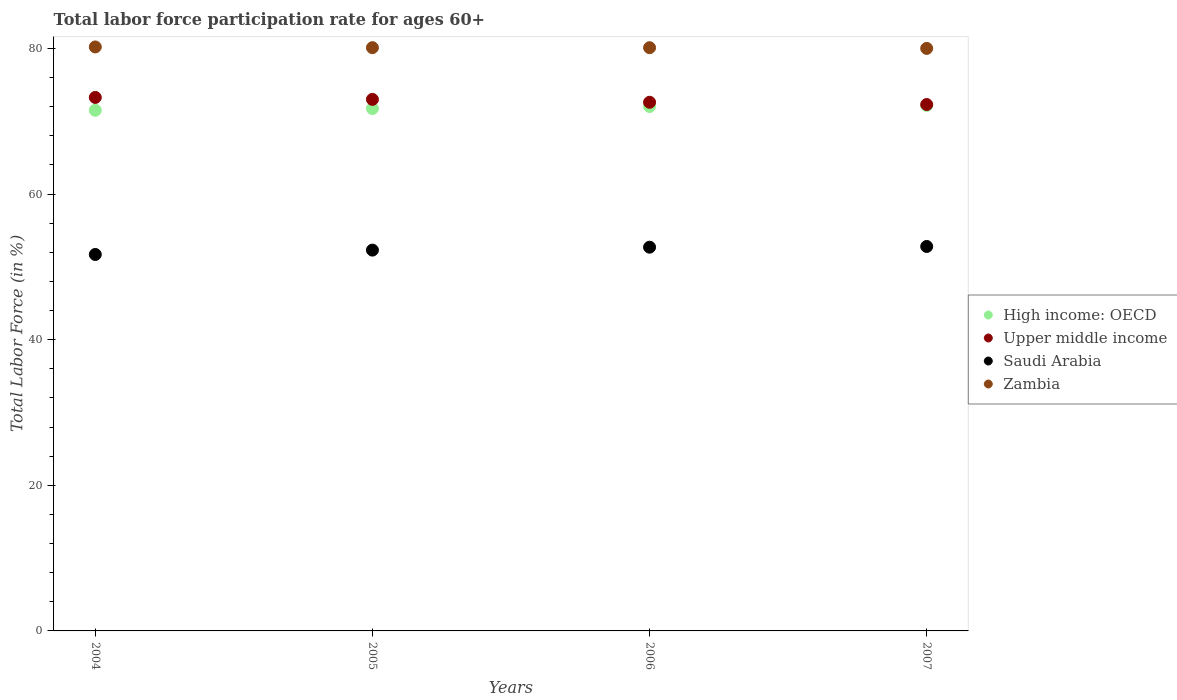What is the labor force participation rate in High income: OECD in 2007?
Your response must be concise. 72.18. Across all years, what is the maximum labor force participation rate in Upper middle income?
Make the answer very short. 73.27. In which year was the labor force participation rate in Saudi Arabia minimum?
Give a very brief answer. 2004. What is the total labor force participation rate in Zambia in the graph?
Offer a very short reply. 320.4. What is the difference between the labor force participation rate in High income: OECD in 2006 and that in 2007?
Offer a terse response. -0.15. What is the difference between the labor force participation rate in Zambia in 2006 and the labor force participation rate in Saudi Arabia in 2005?
Your response must be concise. 27.8. What is the average labor force participation rate in Zambia per year?
Your answer should be very brief. 80.1. In the year 2007, what is the difference between the labor force participation rate in Zambia and labor force participation rate in Saudi Arabia?
Ensure brevity in your answer.  27.2. What is the ratio of the labor force participation rate in Zambia in 2005 to that in 2006?
Ensure brevity in your answer.  1. Is the difference between the labor force participation rate in Zambia in 2005 and 2007 greater than the difference between the labor force participation rate in Saudi Arabia in 2005 and 2007?
Offer a terse response. Yes. What is the difference between the highest and the second highest labor force participation rate in Upper middle income?
Make the answer very short. 0.27. What is the difference between the highest and the lowest labor force participation rate in High income: OECD?
Provide a succinct answer. 0.67. In how many years, is the labor force participation rate in Upper middle income greater than the average labor force participation rate in Upper middle income taken over all years?
Offer a very short reply. 2. Is it the case that in every year, the sum of the labor force participation rate in Saudi Arabia and labor force participation rate in High income: OECD  is greater than the labor force participation rate in Zambia?
Provide a short and direct response. Yes. How many years are there in the graph?
Offer a very short reply. 4. Are the values on the major ticks of Y-axis written in scientific E-notation?
Your response must be concise. No. How many legend labels are there?
Your answer should be compact. 4. How are the legend labels stacked?
Offer a very short reply. Vertical. What is the title of the graph?
Offer a terse response. Total labor force participation rate for ages 60+. Does "Algeria" appear as one of the legend labels in the graph?
Keep it short and to the point. No. What is the label or title of the X-axis?
Your response must be concise. Years. What is the label or title of the Y-axis?
Your answer should be compact. Total Labor Force (in %). What is the Total Labor Force (in %) of High income: OECD in 2004?
Provide a short and direct response. 71.5. What is the Total Labor Force (in %) in Upper middle income in 2004?
Provide a succinct answer. 73.27. What is the Total Labor Force (in %) in Saudi Arabia in 2004?
Provide a succinct answer. 51.7. What is the Total Labor Force (in %) in Zambia in 2004?
Your response must be concise. 80.2. What is the Total Labor Force (in %) in High income: OECD in 2005?
Ensure brevity in your answer.  71.74. What is the Total Labor Force (in %) in Upper middle income in 2005?
Your answer should be very brief. 73. What is the Total Labor Force (in %) in Saudi Arabia in 2005?
Offer a very short reply. 52.3. What is the Total Labor Force (in %) of Zambia in 2005?
Ensure brevity in your answer.  80.1. What is the Total Labor Force (in %) of High income: OECD in 2006?
Ensure brevity in your answer.  72.02. What is the Total Labor Force (in %) in Upper middle income in 2006?
Give a very brief answer. 72.6. What is the Total Labor Force (in %) of Saudi Arabia in 2006?
Give a very brief answer. 52.7. What is the Total Labor Force (in %) in Zambia in 2006?
Your answer should be very brief. 80.1. What is the Total Labor Force (in %) of High income: OECD in 2007?
Give a very brief answer. 72.18. What is the Total Labor Force (in %) of Upper middle income in 2007?
Your answer should be very brief. 72.29. What is the Total Labor Force (in %) in Saudi Arabia in 2007?
Offer a very short reply. 52.8. Across all years, what is the maximum Total Labor Force (in %) of High income: OECD?
Provide a succinct answer. 72.18. Across all years, what is the maximum Total Labor Force (in %) of Upper middle income?
Give a very brief answer. 73.27. Across all years, what is the maximum Total Labor Force (in %) of Saudi Arabia?
Your answer should be compact. 52.8. Across all years, what is the maximum Total Labor Force (in %) in Zambia?
Offer a very short reply. 80.2. Across all years, what is the minimum Total Labor Force (in %) of High income: OECD?
Ensure brevity in your answer.  71.5. Across all years, what is the minimum Total Labor Force (in %) in Upper middle income?
Your response must be concise. 72.29. Across all years, what is the minimum Total Labor Force (in %) in Saudi Arabia?
Keep it short and to the point. 51.7. What is the total Total Labor Force (in %) in High income: OECD in the graph?
Ensure brevity in your answer.  287.44. What is the total Total Labor Force (in %) of Upper middle income in the graph?
Make the answer very short. 291.16. What is the total Total Labor Force (in %) of Saudi Arabia in the graph?
Keep it short and to the point. 209.5. What is the total Total Labor Force (in %) of Zambia in the graph?
Your response must be concise. 320.4. What is the difference between the Total Labor Force (in %) in High income: OECD in 2004 and that in 2005?
Keep it short and to the point. -0.24. What is the difference between the Total Labor Force (in %) in Upper middle income in 2004 and that in 2005?
Your response must be concise. 0.27. What is the difference between the Total Labor Force (in %) of Saudi Arabia in 2004 and that in 2005?
Give a very brief answer. -0.6. What is the difference between the Total Labor Force (in %) in Zambia in 2004 and that in 2005?
Your answer should be very brief. 0.1. What is the difference between the Total Labor Force (in %) in High income: OECD in 2004 and that in 2006?
Ensure brevity in your answer.  -0.52. What is the difference between the Total Labor Force (in %) of Upper middle income in 2004 and that in 2006?
Ensure brevity in your answer.  0.66. What is the difference between the Total Labor Force (in %) in High income: OECD in 2004 and that in 2007?
Keep it short and to the point. -0.67. What is the difference between the Total Labor Force (in %) of Upper middle income in 2004 and that in 2007?
Provide a short and direct response. 0.97. What is the difference between the Total Labor Force (in %) in Saudi Arabia in 2004 and that in 2007?
Offer a terse response. -1.1. What is the difference between the Total Labor Force (in %) of Zambia in 2004 and that in 2007?
Offer a terse response. 0.2. What is the difference between the Total Labor Force (in %) of High income: OECD in 2005 and that in 2006?
Provide a short and direct response. -0.28. What is the difference between the Total Labor Force (in %) of Upper middle income in 2005 and that in 2006?
Give a very brief answer. 0.39. What is the difference between the Total Labor Force (in %) in Zambia in 2005 and that in 2006?
Your answer should be compact. 0. What is the difference between the Total Labor Force (in %) in High income: OECD in 2005 and that in 2007?
Give a very brief answer. -0.43. What is the difference between the Total Labor Force (in %) of Upper middle income in 2005 and that in 2007?
Provide a short and direct response. 0.71. What is the difference between the Total Labor Force (in %) in Saudi Arabia in 2005 and that in 2007?
Provide a short and direct response. -0.5. What is the difference between the Total Labor Force (in %) of High income: OECD in 2006 and that in 2007?
Provide a succinct answer. -0.15. What is the difference between the Total Labor Force (in %) in Upper middle income in 2006 and that in 2007?
Provide a short and direct response. 0.31. What is the difference between the Total Labor Force (in %) of Zambia in 2006 and that in 2007?
Make the answer very short. 0.1. What is the difference between the Total Labor Force (in %) in High income: OECD in 2004 and the Total Labor Force (in %) in Upper middle income in 2005?
Offer a very short reply. -1.5. What is the difference between the Total Labor Force (in %) of High income: OECD in 2004 and the Total Labor Force (in %) of Saudi Arabia in 2005?
Offer a terse response. 19.2. What is the difference between the Total Labor Force (in %) of High income: OECD in 2004 and the Total Labor Force (in %) of Zambia in 2005?
Provide a succinct answer. -8.6. What is the difference between the Total Labor Force (in %) in Upper middle income in 2004 and the Total Labor Force (in %) in Saudi Arabia in 2005?
Offer a very short reply. 20.97. What is the difference between the Total Labor Force (in %) of Upper middle income in 2004 and the Total Labor Force (in %) of Zambia in 2005?
Provide a short and direct response. -6.83. What is the difference between the Total Labor Force (in %) of Saudi Arabia in 2004 and the Total Labor Force (in %) of Zambia in 2005?
Your answer should be very brief. -28.4. What is the difference between the Total Labor Force (in %) of High income: OECD in 2004 and the Total Labor Force (in %) of Upper middle income in 2006?
Ensure brevity in your answer.  -1.1. What is the difference between the Total Labor Force (in %) in High income: OECD in 2004 and the Total Labor Force (in %) in Saudi Arabia in 2006?
Your response must be concise. 18.8. What is the difference between the Total Labor Force (in %) in High income: OECD in 2004 and the Total Labor Force (in %) in Zambia in 2006?
Ensure brevity in your answer.  -8.6. What is the difference between the Total Labor Force (in %) of Upper middle income in 2004 and the Total Labor Force (in %) of Saudi Arabia in 2006?
Keep it short and to the point. 20.57. What is the difference between the Total Labor Force (in %) in Upper middle income in 2004 and the Total Labor Force (in %) in Zambia in 2006?
Provide a succinct answer. -6.83. What is the difference between the Total Labor Force (in %) of Saudi Arabia in 2004 and the Total Labor Force (in %) of Zambia in 2006?
Provide a short and direct response. -28.4. What is the difference between the Total Labor Force (in %) in High income: OECD in 2004 and the Total Labor Force (in %) in Upper middle income in 2007?
Keep it short and to the point. -0.79. What is the difference between the Total Labor Force (in %) in High income: OECD in 2004 and the Total Labor Force (in %) in Saudi Arabia in 2007?
Your response must be concise. 18.7. What is the difference between the Total Labor Force (in %) of High income: OECD in 2004 and the Total Labor Force (in %) of Zambia in 2007?
Your answer should be compact. -8.5. What is the difference between the Total Labor Force (in %) of Upper middle income in 2004 and the Total Labor Force (in %) of Saudi Arabia in 2007?
Ensure brevity in your answer.  20.47. What is the difference between the Total Labor Force (in %) of Upper middle income in 2004 and the Total Labor Force (in %) of Zambia in 2007?
Ensure brevity in your answer.  -6.73. What is the difference between the Total Labor Force (in %) of Saudi Arabia in 2004 and the Total Labor Force (in %) of Zambia in 2007?
Your response must be concise. -28.3. What is the difference between the Total Labor Force (in %) of High income: OECD in 2005 and the Total Labor Force (in %) of Upper middle income in 2006?
Your response must be concise. -0.86. What is the difference between the Total Labor Force (in %) of High income: OECD in 2005 and the Total Labor Force (in %) of Saudi Arabia in 2006?
Provide a succinct answer. 19.04. What is the difference between the Total Labor Force (in %) in High income: OECD in 2005 and the Total Labor Force (in %) in Zambia in 2006?
Provide a short and direct response. -8.36. What is the difference between the Total Labor Force (in %) in Upper middle income in 2005 and the Total Labor Force (in %) in Saudi Arabia in 2006?
Your response must be concise. 20.3. What is the difference between the Total Labor Force (in %) in Upper middle income in 2005 and the Total Labor Force (in %) in Zambia in 2006?
Your answer should be compact. -7.1. What is the difference between the Total Labor Force (in %) of Saudi Arabia in 2005 and the Total Labor Force (in %) of Zambia in 2006?
Offer a terse response. -27.8. What is the difference between the Total Labor Force (in %) in High income: OECD in 2005 and the Total Labor Force (in %) in Upper middle income in 2007?
Your answer should be compact. -0.55. What is the difference between the Total Labor Force (in %) of High income: OECD in 2005 and the Total Labor Force (in %) of Saudi Arabia in 2007?
Your response must be concise. 18.94. What is the difference between the Total Labor Force (in %) in High income: OECD in 2005 and the Total Labor Force (in %) in Zambia in 2007?
Provide a succinct answer. -8.26. What is the difference between the Total Labor Force (in %) of Upper middle income in 2005 and the Total Labor Force (in %) of Saudi Arabia in 2007?
Your answer should be compact. 20.2. What is the difference between the Total Labor Force (in %) in Upper middle income in 2005 and the Total Labor Force (in %) in Zambia in 2007?
Your answer should be compact. -7. What is the difference between the Total Labor Force (in %) of Saudi Arabia in 2005 and the Total Labor Force (in %) of Zambia in 2007?
Ensure brevity in your answer.  -27.7. What is the difference between the Total Labor Force (in %) in High income: OECD in 2006 and the Total Labor Force (in %) in Upper middle income in 2007?
Provide a succinct answer. -0.27. What is the difference between the Total Labor Force (in %) of High income: OECD in 2006 and the Total Labor Force (in %) of Saudi Arabia in 2007?
Provide a short and direct response. 19.22. What is the difference between the Total Labor Force (in %) in High income: OECD in 2006 and the Total Labor Force (in %) in Zambia in 2007?
Your answer should be very brief. -7.98. What is the difference between the Total Labor Force (in %) in Upper middle income in 2006 and the Total Labor Force (in %) in Saudi Arabia in 2007?
Your answer should be very brief. 19.8. What is the difference between the Total Labor Force (in %) in Upper middle income in 2006 and the Total Labor Force (in %) in Zambia in 2007?
Your response must be concise. -7.4. What is the difference between the Total Labor Force (in %) of Saudi Arabia in 2006 and the Total Labor Force (in %) of Zambia in 2007?
Your answer should be very brief. -27.3. What is the average Total Labor Force (in %) of High income: OECD per year?
Offer a terse response. 71.86. What is the average Total Labor Force (in %) in Upper middle income per year?
Offer a very short reply. 72.79. What is the average Total Labor Force (in %) of Saudi Arabia per year?
Your answer should be compact. 52.38. What is the average Total Labor Force (in %) in Zambia per year?
Your answer should be very brief. 80.1. In the year 2004, what is the difference between the Total Labor Force (in %) of High income: OECD and Total Labor Force (in %) of Upper middle income?
Offer a terse response. -1.76. In the year 2004, what is the difference between the Total Labor Force (in %) in High income: OECD and Total Labor Force (in %) in Saudi Arabia?
Your response must be concise. 19.8. In the year 2004, what is the difference between the Total Labor Force (in %) in High income: OECD and Total Labor Force (in %) in Zambia?
Give a very brief answer. -8.7. In the year 2004, what is the difference between the Total Labor Force (in %) of Upper middle income and Total Labor Force (in %) of Saudi Arabia?
Offer a terse response. 21.57. In the year 2004, what is the difference between the Total Labor Force (in %) in Upper middle income and Total Labor Force (in %) in Zambia?
Your response must be concise. -6.93. In the year 2004, what is the difference between the Total Labor Force (in %) in Saudi Arabia and Total Labor Force (in %) in Zambia?
Your response must be concise. -28.5. In the year 2005, what is the difference between the Total Labor Force (in %) in High income: OECD and Total Labor Force (in %) in Upper middle income?
Your response must be concise. -1.26. In the year 2005, what is the difference between the Total Labor Force (in %) in High income: OECD and Total Labor Force (in %) in Saudi Arabia?
Provide a succinct answer. 19.44. In the year 2005, what is the difference between the Total Labor Force (in %) in High income: OECD and Total Labor Force (in %) in Zambia?
Provide a short and direct response. -8.36. In the year 2005, what is the difference between the Total Labor Force (in %) in Upper middle income and Total Labor Force (in %) in Saudi Arabia?
Provide a short and direct response. 20.7. In the year 2005, what is the difference between the Total Labor Force (in %) of Upper middle income and Total Labor Force (in %) of Zambia?
Your answer should be compact. -7.1. In the year 2005, what is the difference between the Total Labor Force (in %) of Saudi Arabia and Total Labor Force (in %) of Zambia?
Keep it short and to the point. -27.8. In the year 2006, what is the difference between the Total Labor Force (in %) of High income: OECD and Total Labor Force (in %) of Upper middle income?
Give a very brief answer. -0.58. In the year 2006, what is the difference between the Total Labor Force (in %) in High income: OECD and Total Labor Force (in %) in Saudi Arabia?
Your answer should be compact. 19.32. In the year 2006, what is the difference between the Total Labor Force (in %) in High income: OECD and Total Labor Force (in %) in Zambia?
Keep it short and to the point. -8.08. In the year 2006, what is the difference between the Total Labor Force (in %) of Upper middle income and Total Labor Force (in %) of Saudi Arabia?
Provide a succinct answer. 19.9. In the year 2006, what is the difference between the Total Labor Force (in %) of Upper middle income and Total Labor Force (in %) of Zambia?
Your answer should be compact. -7.5. In the year 2006, what is the difference between the Total Labor Force (in %) of Saudi Arabia and Total Labor Force (in %) of Zambia?
Ensure brevity in your answer.  -27.4. In the year 2007, what is the difference between the Total Labor Force (in %) in High income: OECD and Total Labor Force (in %) in Upper middle income?
Offer a terse response. -0.12. In the year 2007, what is the difference between the Total Labor Force (in %) in High income: OECD and Total Labor Force (in %) in Saudi Arabia?
Your response must be concise. 19.38. In the year 2007, what is the difference between the Total Labor Force (in %) of High income: OECD and Total Labor Force (in %) of Zambia?
Provide a short and direct response. -7.82. In the year 2007, what is the difference between the Total Labor Force (in %) of Upper middle income and Total Labor Force (in %) of Saudi Arabia?
Provide a succinct answer. 19.49. In the year 2007, what is the difference between the Total Labor Force (in %) in Upper middle income and Total Labor Force (in %) in Zambia?
Your answer should be very brief. -7.71. In the year 2007, what is the difference between the Total Labor Force (in %) of Saudi Arabia and Total Labor Force (in %) of Zambia?
Your response must be concise. -27.2. What is the ratio of the Total Labor Force (in %) of Upper middle income in 2004 to that in 2005?
Make the answer very short. 1. What is the ratio of the Total Labor Force (in %) of Saudi Arabia in 2004 to that in 2005?
Your response must be concise. 0.99. What is the ratio of the Total Labor Force (in %) of High income: OECD in 2004 to that in 2006?
Provide a succinct answer. 0.99. What is the ratio of the Total Labor Force (in %) of Upper middle income in 2004 to that in 2006?
Provide a succinct answer. 1.01. What is the ratio of the Total Labor Force (in %) of Saudi Arabia in 2004 to that in 2006?
Provide a short and direct response. 0.98. What is the ratio of the Total Labor Force (in %) in Zambia in 2004 to that in 2006?
Offer a very short reply. 1. What is the ratio of the Total Labor Force (in %) of High income: OECD in 2004 to that in 2007?
Provide a succinct answer. 0.99. What is the ratio of the Total Labor Force (in %) of Upper middle income in 2004 to that in 2007?
Your answer should be compact. 1.01. What is the ratio of the Total Labor Force (in %) in Saudi Arabia in 2004 to that in 2007?
Ensure brevity in your answer.  0.98. What is the ratio of the Total Labor Force (in %) in High income: OECD in 2005 to that in 2006?
Your response must be concise. 1. What is the ratio of the Total Labor Force (in %) in Upper middle income in 2005 to that in 2006?
Make the answer very short. 1.01. What is the ratio of the Total Labor Force (in %) of Saudi Arabia in 2005 to that in 2006?
Your answer should be very brief. 0.99. What is the ratio of the Total Labor Force (in %) in Zambia in 2005 to that in 2006?
Make the answer very short. 1. What is the ratio of the Total Labor Force (in %) of High income: OECD in 2005 to that in 2007?
Offer a very short reply. 0.99. What is the ratio of the Total Labor Force (in %) of Upper middle income in 2005 to that in 2007?
Provide a short and direct response. 1.01. What is the ratio of the Total Labor Force (in %) in Zambia in 2005 to that in 2007?
Your response must be concise. 1. What is the ratio of the Total Labor Force (in %) of Upper middle income in 2006 to that in 2007?
Your answer should be compact. 1. What is the difference between the highest and the second highest Total Labor Force (in %) of High income: OECD?
Offer a very short reply. 0.15. What is the difference between the highest and the second highest Total Labor Force (in %) of Upper middle income?
Offer a very short reply. 0.27. What is the difference between the highest and the lowest Total Labor Force (in %) of High income: OECD?
Offer a very short reply. 0.67. What is the difference between the highest and the lowest Total Labor Force (in %) in Upper middle income?
Make the answer very short. 0.97. What is the difference between the highest and the lowest Total Labor Force (in %) in Saudi Arabia?
Offer a terse response. 1.1. What is the difference between the highest and the lowest Total Labor Force (in %) in Zambia?
Make the answer very short. 0.2. 